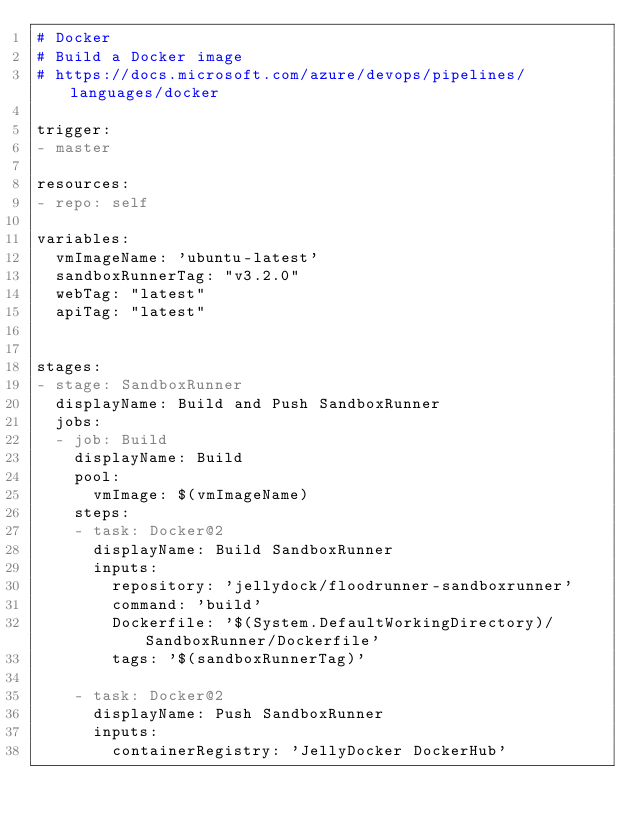Convert code to text. <code><loc_0><loc_0><loc_500><loc_500><_YAML_># Docker
# Build a Docker image 
# https://docs.microsoft.com/azure/devops/pipelines/languages/docker

trigger:
- master

resources:
- repo: self

variables:
  vmImageName: 'ubuntu-latest'
  sandboxRunnerTag: "v3.2.0"
  webTag: "latest"
  apiTag: "latest"
  

stages:
- stage: SandboxRunner
  displayName: Build and Push SandboxRunner
  jobs:  
  - job: Build
    displayName: Build
    pool:
      vmImage: $(vmImageName)
    steps:
    - task: Docker@2
      displayName: Build SandboxRunner
      inputs:
        repository: 'jellydock/floodrunner-sandboxrunner'
        command: 'build'
        Dockerfile: '$(System.DefaultWorkingDirectory)/SandboxRunner/Dockerfile'
        tags: '$(sandboxRunnerTag)'

    - task: Docker@2
      displayName: Push SandboxRunner
      inputs:
        containerRegistry: 'JellyDocker DockerHub'</code> 